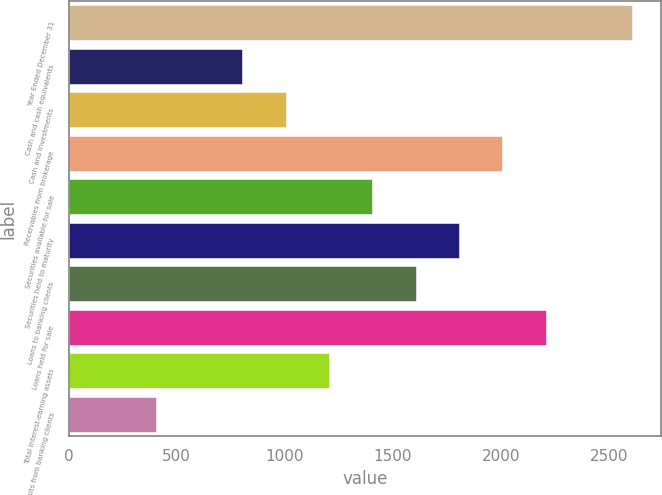Convert chart to OTSL. <chart><loc_0><loc_0><loc_500><loc_500><bar_chart><fcel>Year Ended December 31<fcel>Cash and cash equivalents<fcel>Cash and investments<fcel>Receivables from brokerage<fcel>Securities available for sale<fcel>Securities held to maturity<fcel>Loans to banking clients<fcel>Loans held for sale<fcel>Total interest-earning assets<fcel>Deposits from banking clients<nl><fcel>2610.24<fcel>803.4<fcel>1004.16<fcel>2007.96<fcel>1405.68<fcel>1807.2<fcel>1606.44<fcel>2208.72<fcel>1204.92<fcel>401.88<nl></chart> 